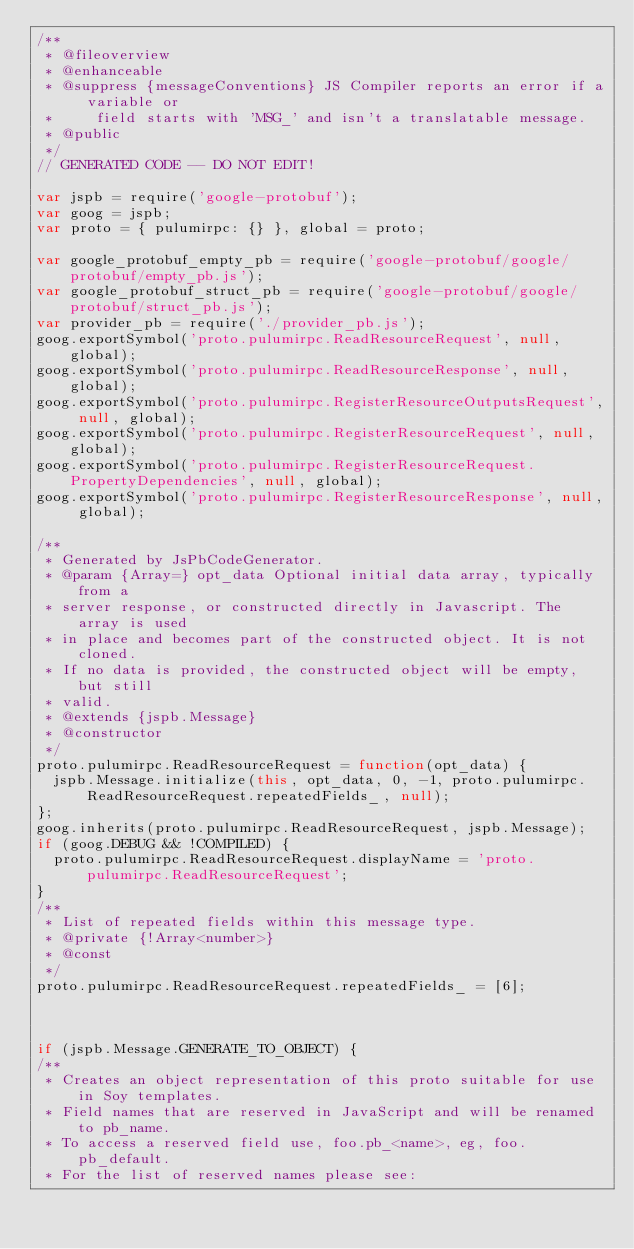<code> <loc_0><loc_0><loc_500><loc_500><_JavaScript_>/**
 * @fileoverview
 * @enhanceable
 * @suppress {messageConventions} JS Compiler reports an error if a variable or
 *     field starts with 'MSG_' and isn't a translatable message.
 * @public
 */
// GENERATED CODE -- DO NOT EDIT!

var jspb = require('google-protobuf');
var goog = jspb;
var proto = { pulumirpc: {} }, global = proto;

var google_protobuf_empty_pb = require('google-protobuf/google/protobuf/empty_pb.js');
var google_protobuf_struct_pb = require('google-protobuf/google/protobuf/struct_pb.js');
var provider_pb = require('./provider_pb.js');
goog.exportSymbol('proto.pulumirpc.ReadResourceRequest', null, global);
goog.exportSymbol('proto.pulumirpc.ReadResourceResponse', null, global);
goog.exportSymbol('proto.pulumirpc.RegisterResourceOutputsRequest', null, global);
goog.exportSymbol('proto.pulumirpc.RegisterResourceRequest', null, global);
goog.exportSymbol('proto.pulumirpc.RegisterResourceRequest.PropertyDependencies', null, global);
goog.exportSymbol('proto.pulumirpc.RegisterResourceResponse', null, global);

/**
 * Generated by JsPbCodeGenerator.
 * @param {Array=} opt_data Optional initial data array, typically from a
 * server response, or constructed directly in Javascript. The array is used
 * in place and becomes part of the constructed object. It is not cloned.
 * If no data is provided, the constructed object will be empty, but still
 * valid.
 * @extends {jspb.Message}
 * @constructor
 */
proto.pulumirpc.ReadResourceRequest = function(opt_data) {
  jspb.Message.initialize(this, opt_data, 0, -1, proto.pulumirpc.ReadResourceRequest.repeatedFields_, null);
};
goog.inherits(proto.pulumirpc.ReadResourceRequest, jspb.Message);
if (goog.DEBUG && !COMPILED) {
  proto.pulumirpc.ReadResourceRequest.displayName = 'proto.pulumirpc.ReadResourceRequest';
}
/**
 * List of repeated fields within this message type.
 * @private {!Array<number>}
 * @const
 */
proto.pulumirpc.ReadResourceRequest.repeatedFields_ = [6];



if (jspb.Message.GENERATE_TO_OBJECT) {
/**
 * Creates an object representation of this proto suitable for use in Soy templates.
 * Field names that are reserved in JavaScript and will be renamed to pb_name.
 * To access a reserved field use, foo.pb_<name>, eg, foo.pb_default.
 * For the list of reserved names please see:</code> 